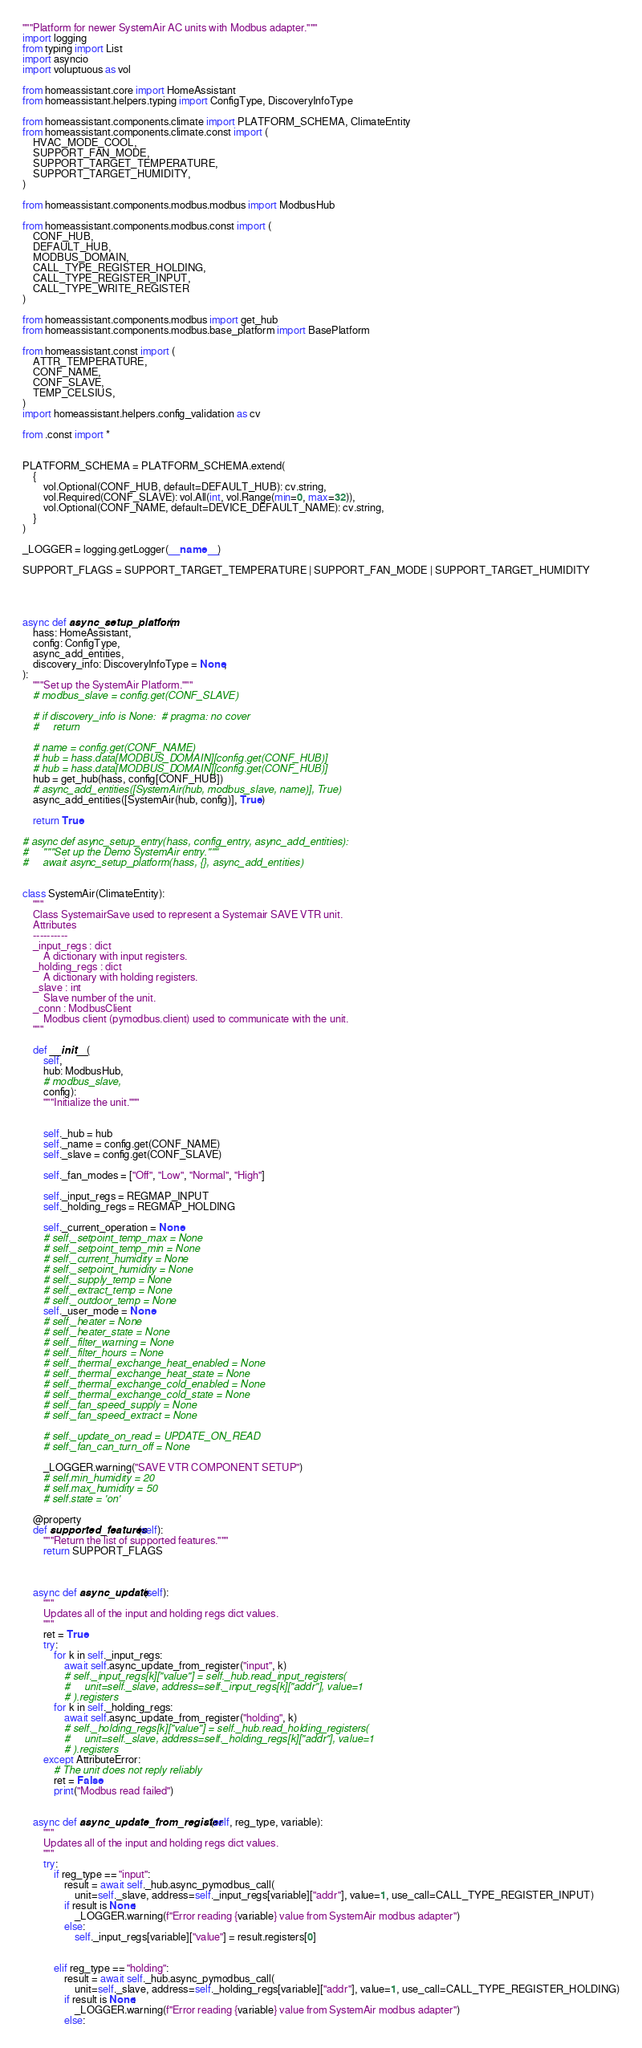Convert code to text. <code><loc_0><loc_0><loc_500><loc_500><_Python_>"""Platform for newer SystemAir AC units with Modbus adapter."""
import logging
from typing import List
import asyncio
import voluptuous as vol

from homeassistant.core import HomeAssistant
from homeassistant.helpers.typing import ConfigType, DiscoveryInfoType

from homeassistant.components.climate import PLATFORM_SCHEMA, ClimateEntity
from homeassistant.components.climate.const import (
    HVAC_MODE_COOL,
    SUPPORT_FAN_MODE,
    SUPPORT_TARGET_TEMPERATURE,
    SUPPORT_TARGET_HUMIDITY,
)

from homeassistant.components.modbus.modbus import ModbusHub

from homeassistant.components.modbus.const import (
    CONF_HUB, 
    DEFAULT_HUB, 
    MODBUS_DOMAIN,
    CALL_TYPE_REGISTER_HOLDING,
    CALL_TYPE_REGISTER_INPUT,
    CALL_TYPE_WRITE_REGISTER
)

from homeassistant.components.modbus import get_hub
from homeassistant.components.modbus.base_platform import BasePlatform

from homeassistant.const import (
    ATTR_TEMPERATURE,
    CONF_NAME,
    CONF_SLAVE,
    TEMP_CELSIUS,
)
import homeassistant.helpers.config_validation as cv

from .const import *


PLATFORM_SCHEMA = PLATFORM_SCHEMA.extend(
    {
        vol.Optional(CONF_HUB, default=DEFAULT_HUB): cv.string,
        vol.Required(CONF_SLAVE): vol.All(int, vol.Range(min=0, max=32)),
        vol.Optional(CONF_NAME, default=DEVICE_DEFAULT_NAME): cv.string,
    }
)

_LOGGER = logging.getLogger(__name__)

SUPPORT_FLAGS = SUPPORT_TARGET_TEMPERATURE | SUPPORT_FAN_MODE | SUPPORT_TARGET_HUMIDITY




async def async_setup_platform(
    hass: HomeAssistant,
    config: ConfigType,
    async_add_entities,
    discovery_info: DiscoveryInfoType = None,
):
    """Set up the SystemAir Platform."""
    # modbus_slave = config.get(CONF_SLAVE)

    # if discovery_info is None:  # pragma: no cover
    #     return

    # name = config.get(CONF_NAME)
    # hub = hass.data[MODBUS_DOMAIN][config.get(CONF_HUB)]
    # hub = hass.data[MODBUS_DOMAIN][config.get(CONF_HUB)]
    hub = get_hub(hass, config[CONF_HUB])
    # async_add_entities([SystemAir(hub, modbus_slave, name)], True)
    async_add_entities([SystemAir(hub, config)], True)
    
    return True

# async def async_setup_entry(hass, config_entry, async_add_entities):
#     """Set up the Demo SystemAir entry."""
#     await async_setup_platform(hass, {}, async_add_entities)


class SystemAir(ClimateEntity):
    """
    Class SystemairSave used to represent a Systemair SAVE VTR unit.
    Attributes
    ----------
    _input_regs : dict
        A dictionary with input registers.
    _holding_regs : dict
        A dictionary with holding registers.
    _slave : int
        Slave number of the unit.
    _conn : ModbusClient
        Modbus client (pymodbus.client) used to communicate with the unit.
    """

    def __init__(
        self, 
        hub: ModbusHub, 
        # modbus_slave, 
        config):
        """Initialize the unit."""


        self._hub = hub
        self._name = config.get(CONF_NAME)
        self._slave = config.get(CONF_SLAVE)

        self._fan_modes = ["Off", "Low", "Normal", "High"]

        self._input_regs = REGMAP_INPUT
        self._holding_regs = REGMAP_HOLDING

        self._current_operation = None
        # self._setpoint_temp_max = None
        # self._setpoint_temp_min = None
        # self._current_humidity = None
        # self._setpoint_humidity = None
        # self._supply_temp = None
        # self._extract_temp = None
        # self._outdoor_temp = None
        self._user_mode = None
        # self._heater = None
        # self._heater_state = None
        # self._filter_warning = None
        # self._filter_hours = None
        # self._thermal_exchange_heat_enabled = None
        # self._thermal_exchange_heat_state = None
        # self._thermal_exchange_cold_enabled = None
        # self._thermal_exchange_cold_state = None
        # self._fan_speed_supply = None
        # self._fan_speed_extract = None

        # self._update_on_read = UPDATE_ON_READ
        # self._fan_can_turn_off = None

        _LOGGER.warning("SAVE VTR COMPONENT SETUP")
        # self.min_humidity = 20
        # self.max_humidity = 50
        # self.state = 'on'

    @property
    def supported_features(self):
        """Return the list of supported features."""
        return SUPPORT_FLAGS



    async def async_update(self):
        """
        Updates all of the input and holding regs dict values.
        """
        ret = True
        try:
            for k in self._input_regs:
                await self.async_update_from_register("input", k)
                # self._input_regs[k]["value"] = self._hub.read_input_registers(
                #     unit=self._slave, address=self._input_regs[k]["addr"], value=1
                # ).registers
            for k in self._holding_regs:
                await self.async_update_from_register("holding", k)
                # self._holding_regs[k]["value"] = self._hub.read_holding_registers(
                #     unit=self._slave, address=self._holding_regs[k]["addr"], value=1
                # ).registers
        except AttributeError:
            # The unit does not reply reliably
            ret = False
            print("Modbus read failed")


    async def async_update_from_register(self, reg_type, variable):
        """
        Updates all of the input and holding regs dict values.
        """
        try:
            if reg_type == "input":
                result = await self._hub.async_pymodbus_call(
                    unit=self._slave, address=self._input_regs[variable]["addr"], value=1, use_call=CALL_TYPE_REGISTER_INPUT)
                if result is None:
                    _LOGGER.warning(f"Error reading {variable} value from SystemAir modbus adapter")
                else:
                    self._input_regs[variable]["value"] = result.registers[0]


            elif reg_type == "holding":
                result = await self._hub.async_pymodbus_call(
                    unit=self._slave, address=self._holding_regs[variable]["addr"], value=1, use_call=CALL_TYPE_REGISTER_HOLDING)
                if result is None:
                    _LOGGER.warning(f"Error reading {variable} value from SystemAir modbus adapter")
                else:</code> 